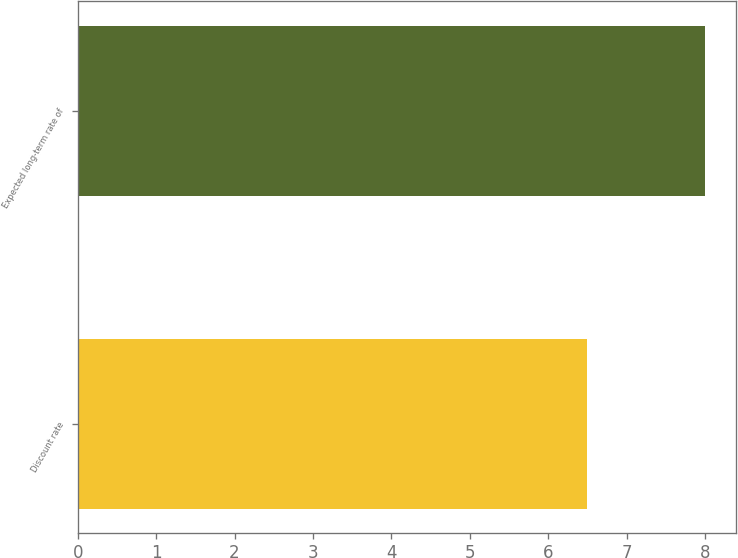Convert chart to OTSL. <chart><loc_0><loc_0><loc_500><loc_500><bar_chart><fcel>Discount rate<fcel>Expected long-term rate of<nl><fcel>6.5<fcel>8<nl></chart> 